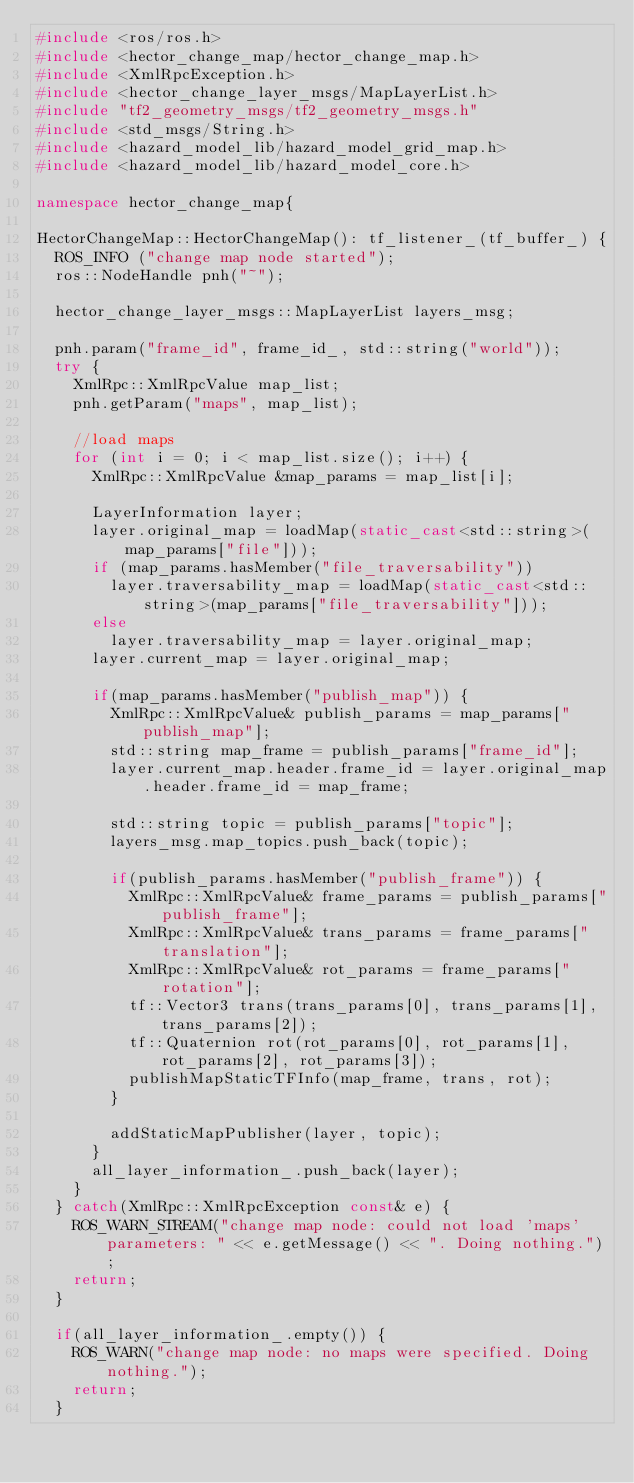<code> <loc_0><loc_0><loc_500><loc_500><_C++_>#include <ros/ros.h>
#include <hector_change_map/hector_change_map.h>
#include <XmlRpcException.h>
#include <hector_change_layer_msgs/MapLayerList.h>
#include "tf2_geometry_msgs/tf2_geometry_msgs.h"
#include <std_msgs/String.h>
#include <hazard_model_lib/hazard_model_grid_map.h>
#include <hazard_model_lib/hazard_model_core.h>

namespace hector_change_map{

HectorChangeMap::HectorChangeMap(): tf_listener_(tf_buffer_) {
  ROS_INFO ("change map node started");
  ros::NodeHandle pnh("~");

  hector_change_layer_msgs::MapLayerList layers_msg;

  pnh.param("frame_id", frame_id_, std::string("world"));
  try {
    XmlRpc::XmlRpcValue map_list;
    pnh.getParam("maps", map_list);
    
    //load maps
    for (int i = 0; i < map_list.size(); i++) {
      XmlRpc::XmlRpcValue &map_params = map_list[i];

      LayerInformation layer;
      layer.original_map = loadMap(static_cast<std::string>(map_params["file"]));
      if (map_params.hasMember("file_traversability"))
        layer.traversability_map = loadMap(static_cast<std::string>(map_params["file_traversability"]));
      else
        layer.traversability_map = layer.original_map;
      layer.current_map = layer.original_map;
      
      if(map_params.hasMember("publish_map")) {
        XmlRpc::XmlRpcValue& publish_params = map_params["publish_map"];
        std::string map_frame = publish_params["frame_id"];
        layer.current_map.header.frame_id = layer.original_map.header.frame_id = map_frame;
        
        std::string topic = publish_params["topic"];
        layers_msg.map_topics.push_back(topic);
        
        if(publish_params.hasMember("publish_frame")) {
          XmlRpc::XmlRpcValue& frame_params = publish_params["publish_frame"];
          XmlRpc::XmlRpcValue& trans_params = frame_params["translation"];
          XmlRpc::XmlRpcValue& rot_params = frame_params["rotation"];
          tf::Vector3 trans(trans_params[0], trans_params[1], trans_params[2]);
          tf::Quaternion rot(rot_params[0], rot_params[1], rot_params[2], rot_params[3]);
          publishMapStaticTFInfo(map_frame, trans, rot);
        }
  
        addStaticMapPublisher(layer, topic);
      }
      all_layer_information_.push_back(layer);
    }
  } catch(XmlRpc::XmlRpcException const& e) {
    ROS_WARN_STREAM("change map node: could not load 'maps' parameters: " << e.getMessage() << ". Doing nothing.");
    return;
  }
  
  if(all_layer_information_.empty()) {
    ROS_WARN("change map node: no maps were specified. Doing nothing.");
    return;
  }
</code> 